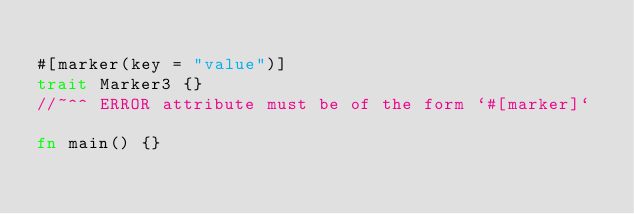<code> <loc_0><loc_0><loc_500><loc_500><_Rust_>
#[marker(key = "value")]
trait Marker3 {}
//~^^ ERROR attribute must be of the form `#[marker]`

fn main() {}
</code> 